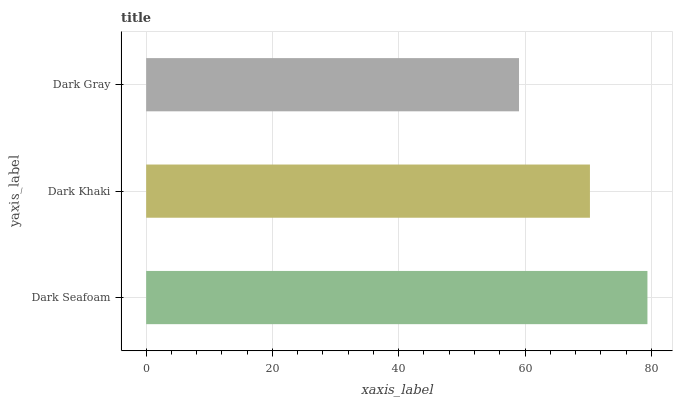Is Dark Gray the minimum?
Answer yes or no. Yes. Is Dark Seafoam the maximum?
Answer yes or no. Yes. Is Dark Khaki the minimum?
Answer yes or no. No. Is Dark Khaki the maximum?
Answer yes or no. No. Is Dark Seafoam greater than Dark Khaki?
Answer yes or no. Yes. Is Dark Khaki less than Dark Seafoam?
Answer yes or no. Yes. Is Dark Khaki greater than Dark Seafoam?
Answer yes or no. No. Is Dark Seafoam less than Dark Khaki?
Answer yes or no. No. Is Dark Khaki the high median?
Answer yes or no. Yes. Is Dark Khaki the low median?
Answer yes or no. Yes. Is Dark Gray the high median?
Answer yes or no. No. Is Dark Seafoam the low median?
Answer yes or no. No. 